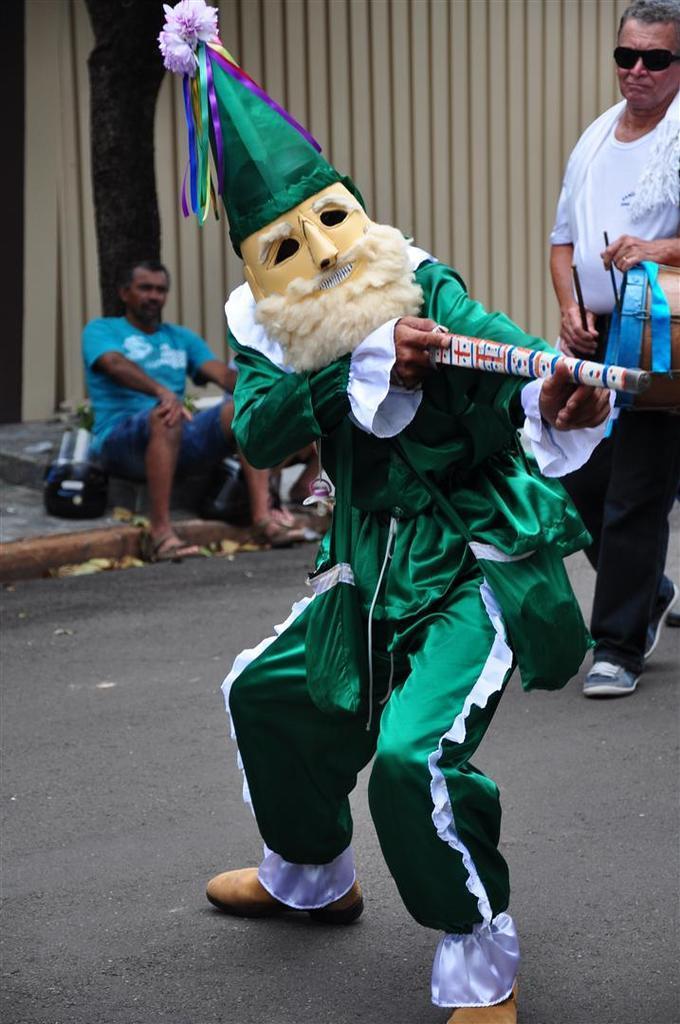Describe this image in one or two sentences. In this picture there is a man who is wearing cap, mask, green dress, shoes and holding sticks. Behind him there is another man who is playing a drum. On the left there is a man who is sitting on the floor. Besides him I can see the bag and wooden partition. 